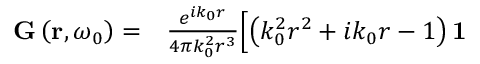Convert formula to latex. <formula><loc_0><loc_0><loc_500><loc_500>\begin{array} { r l } { G \left ( r , \omega _ { 0 } \right ) = } & \frac { e ^ { i k _ { 0 } r } } { 4 \pi k _ { 0 } ^ { 2 } r ^ { 3 } } \Big [ \left ( k _ { 0 } ^ { 2 } r ^ { 2 } + i k _ { 0 } r - 1 \right ) 1 } \end{array}</formula> 